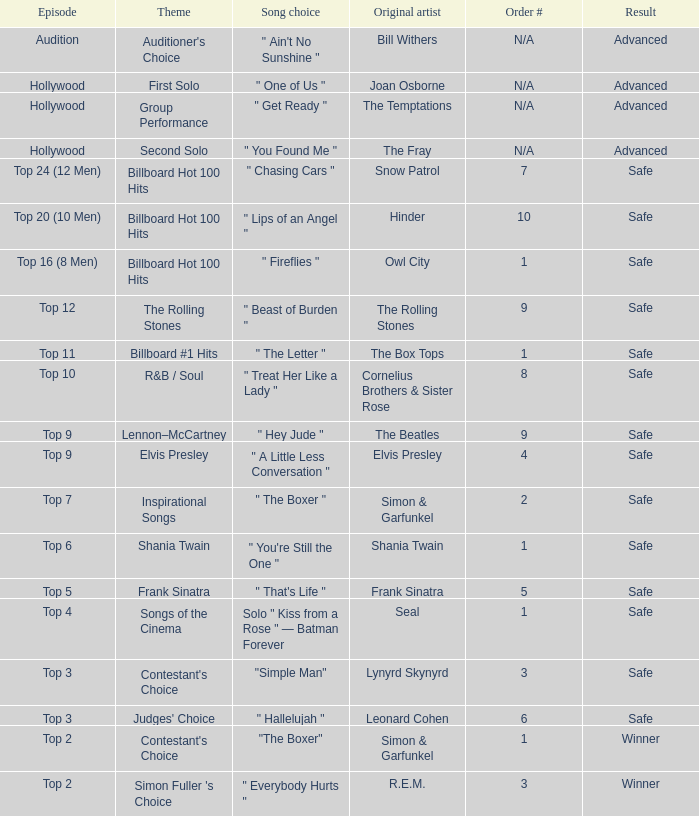The original artist Joan Osborne has what result? Advanced. 